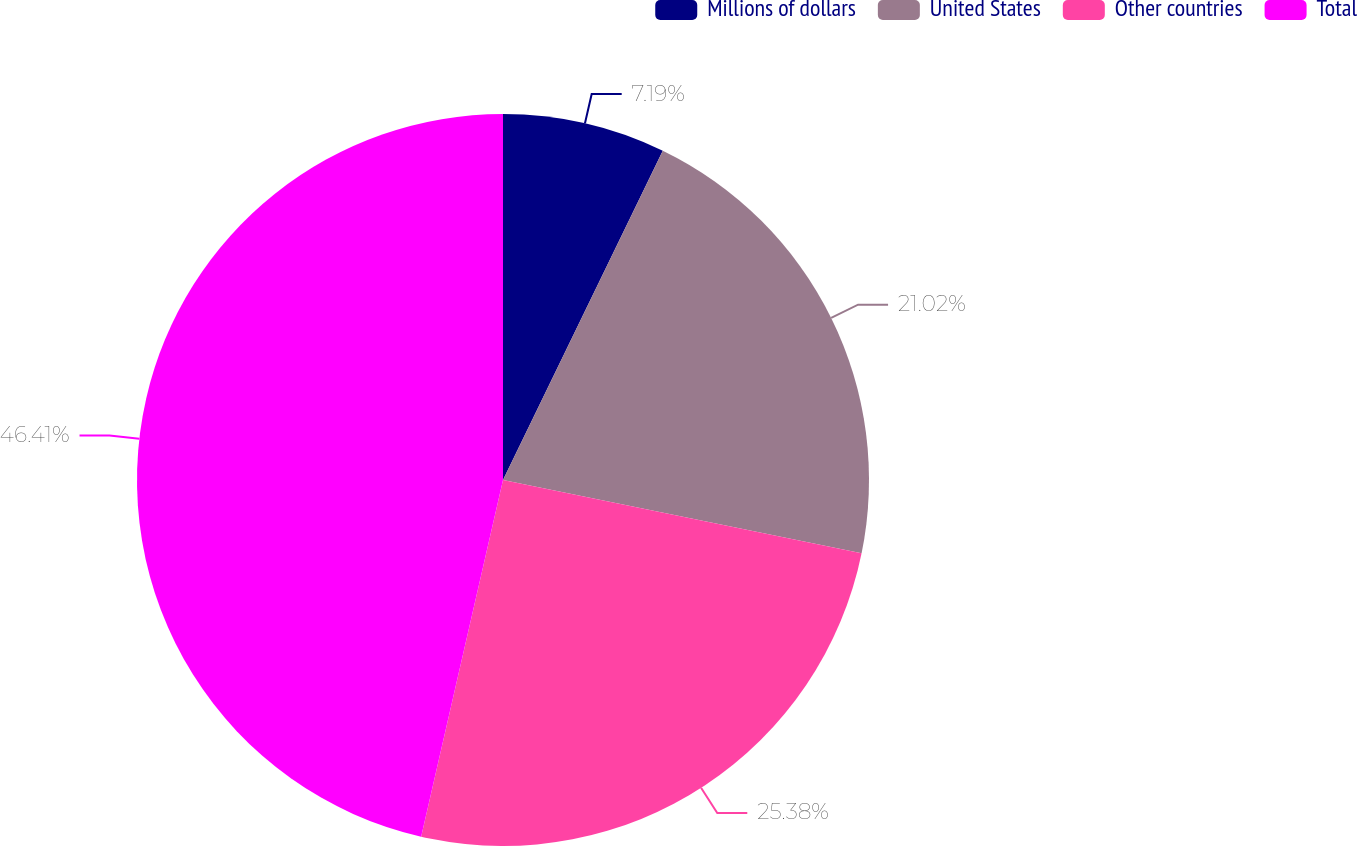Convert chart. <chart><loc_0><loc_0><loc_500><loc_500><pie_chart><fcel>Millions of dollars<fcel>United States<fcel>Other countries<fcel>Total<nl><fcel>7.19%<fcel>21.02%<fcel>25.38%<fcel>46.41%<nl></chart> 